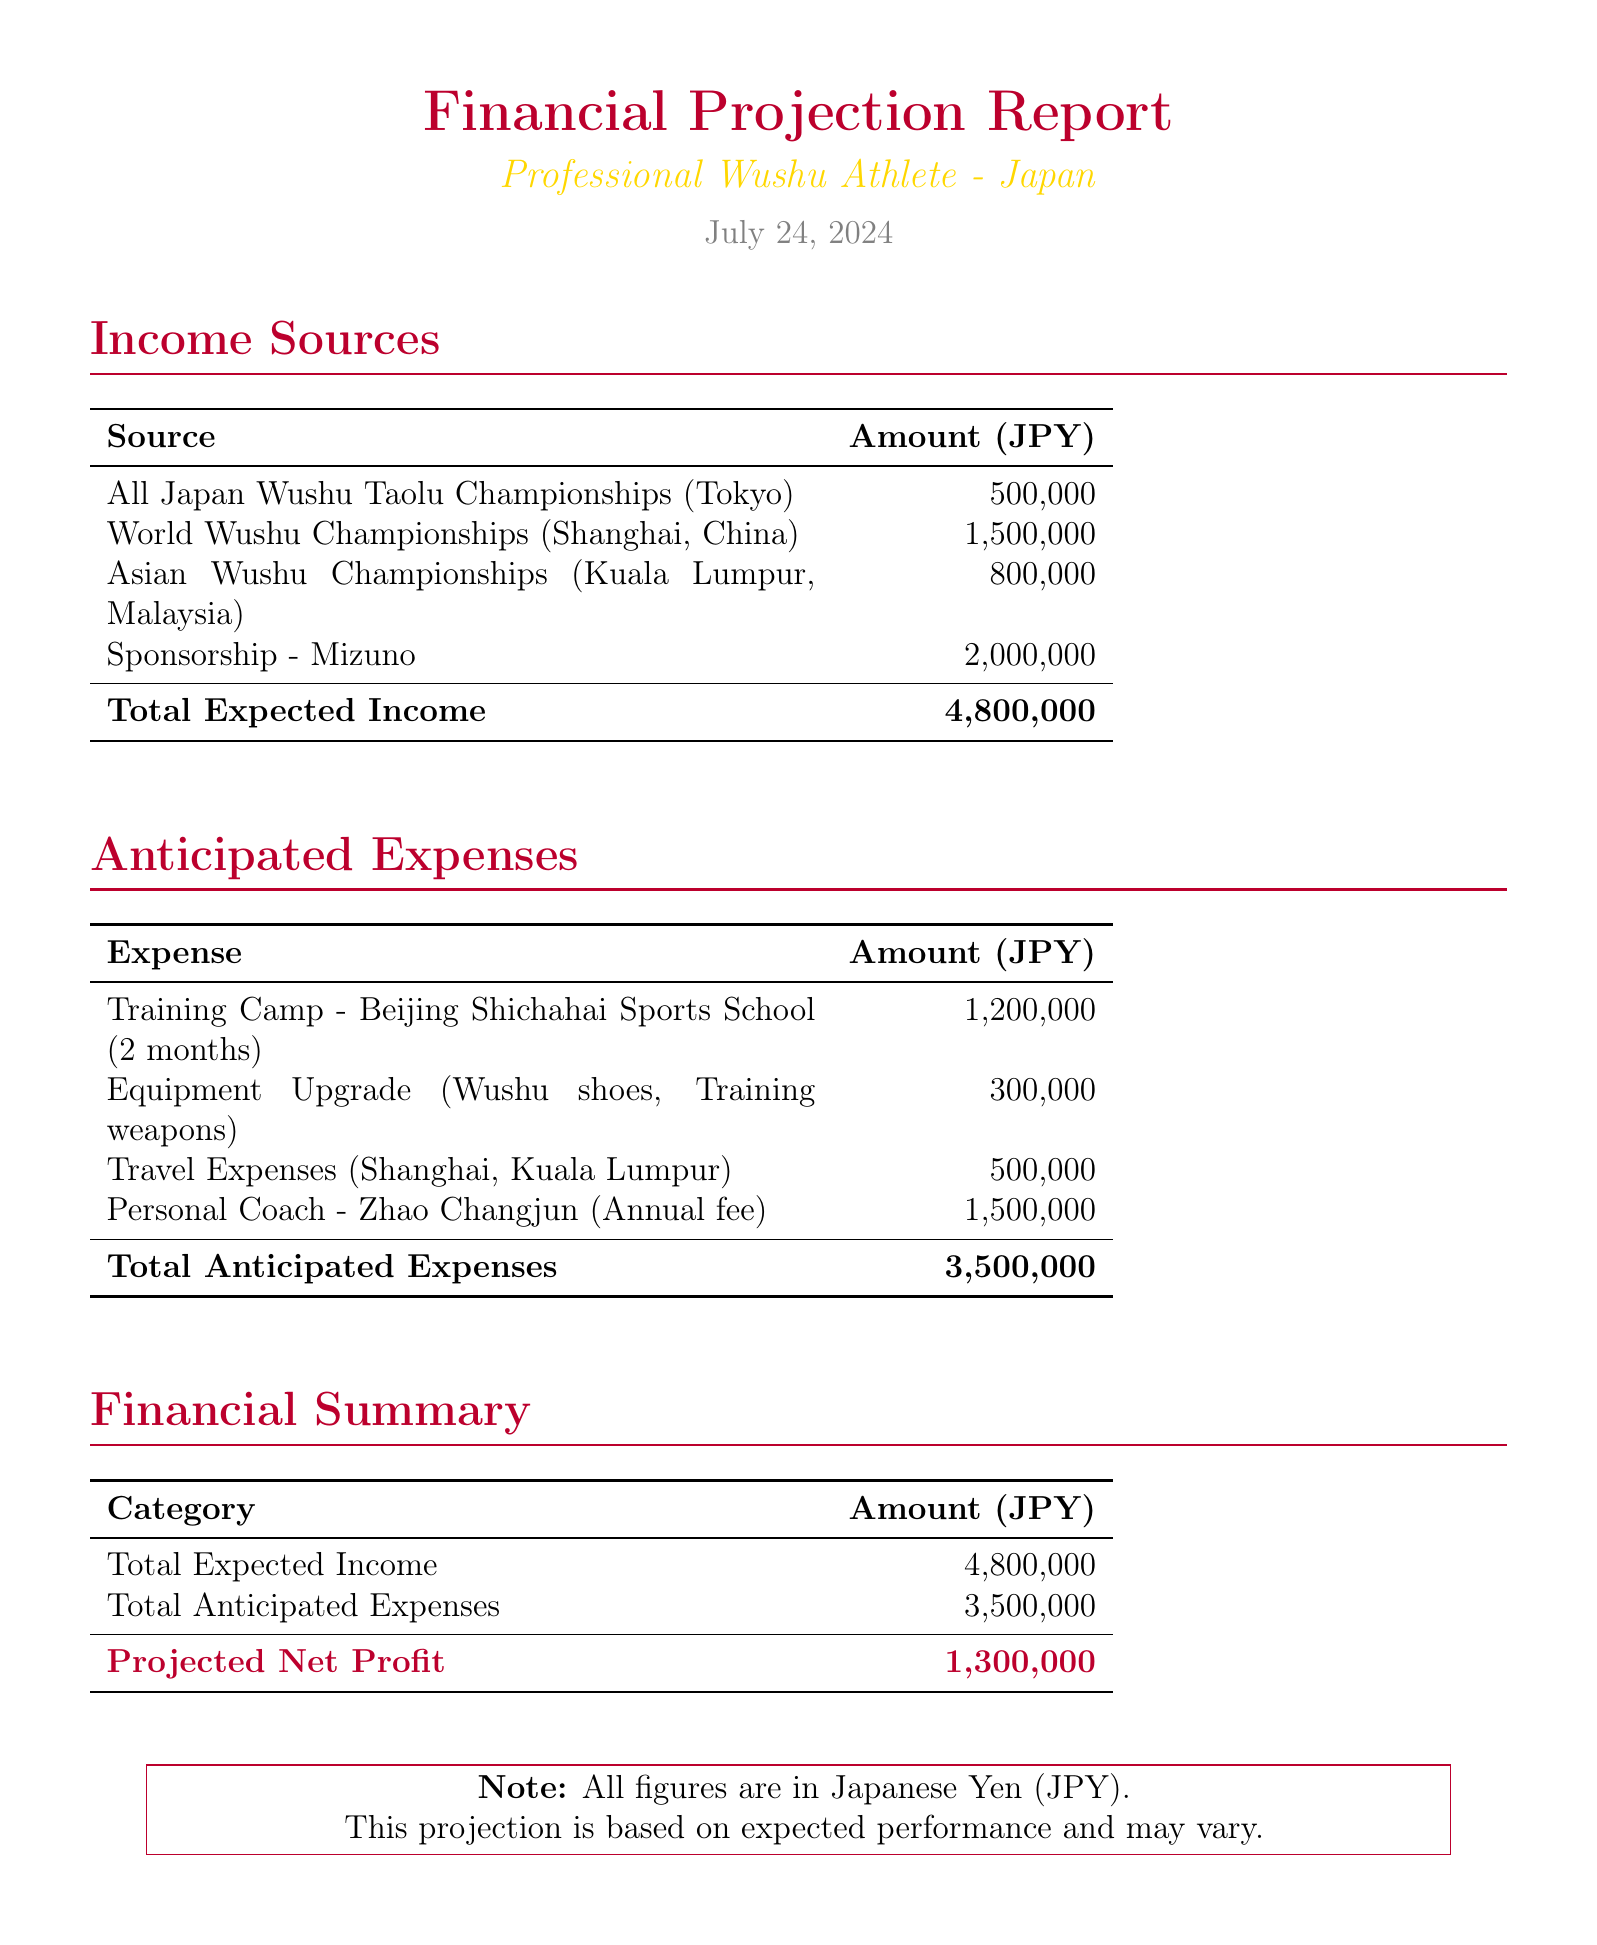What is the expected income from the World Wushu Championships? The expected income from the World Wushu Championships is specified in the document, amounting to 1,500,000 JPY.
Answer: 1,500,000 JPY What is the total anticipated expenses? The total anticipated expenses are clearly stated in the summary section of the document, which sums up all expenses listed.
Answer: 3,500,000 JPY How much is the sponsorship from Mizuno? The expected income from the sponsorship by Mizuno is indicated, which contributes significantly to the total expected income.
Answer: 2,000,000 JPY What is the duration of the training camp? The duration of the training camp at Beijing Shichahai Sports School is mentioned in the expenses section of the document.
Answer: 2 months What is the projected net profit? The projected net profit is calculated by subtracting total anticipated expenses from total expected income, and it is presented in the financial summary section.
Answer: 1,300,000 JPY What are the total expected income sources listed? The document lists multiple income sources contributing to the total expected income figure.
Answer: 4,800,000 JPY How much is allocated for equipment upgrades? The cost for upgrading equipment, such as shoes and training weapons, is detailed in the expenses section.
Answer: 300,000 JPY What are the travel expenses destinations? The travel expenses section specifies the locations intended for travel related to competitions.
Answer: Shanghai, Kuala Lumpur What is the annual fee for the personal coach? The annual fee for the personal coach Zhao Changjun is stated in the document under anticipated expenses.
Answer: 1,500,000 JPY 